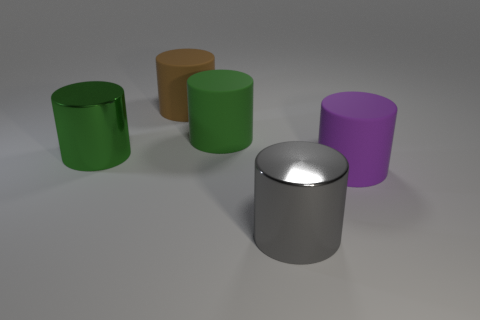Are there more big gray shiny things than large matte things?
Keep it short and to the point. No. How many objects are either brown cylinders or matte cylinders left of the large gray cylinder?
Give a very brief answer. 2. How many other things are there of the same shape as the big brown object?
Offer a very short reply. 4. Is the number of big purple matte things that are behind the purple object less than the number of brown matte things in front of the big gray shiny object?
Provide a short and direct response. No. Is there any other thing that has the same material as the big purple cylinder?
Provide a succinct answer. Yes. What shape is the green object that is made of the same material as the purple object?
Give a very brief answer. Cylinder. There is a big metallic cylinder that is behind the cylinder that is on the right side of the gray metallic cylinder; what color is it?
Provide a succinct answer. Green. What is the material of the big cylinder behind the green object that is on the right side of the green cylinder that is on the left side of the large green matte thing?
Keep it short and to the point. Rubber. What number of purple objects have the same size as the green shiny cylinder?
Offer a very short reply. 1. The cylinder that is behind the big green shiny cylinder and in front of the large brown thing is made of what material?
Offer a very short reply. Rubber. 